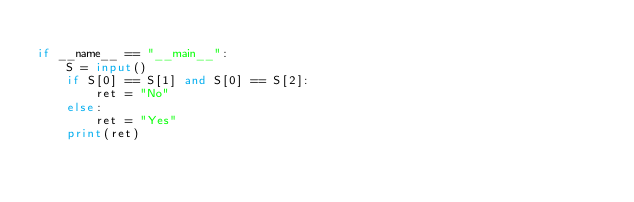Convert code to text. <code><loc_0><loc_0><loc_500><loc_500><_Python_>
if __name__ == "__main__":
    S = input()
    if S[0] == S[1] and S[0] == S[2]:
        ret = "No"
    else:
        ret = "Yes"
    print(ret)
</code> 